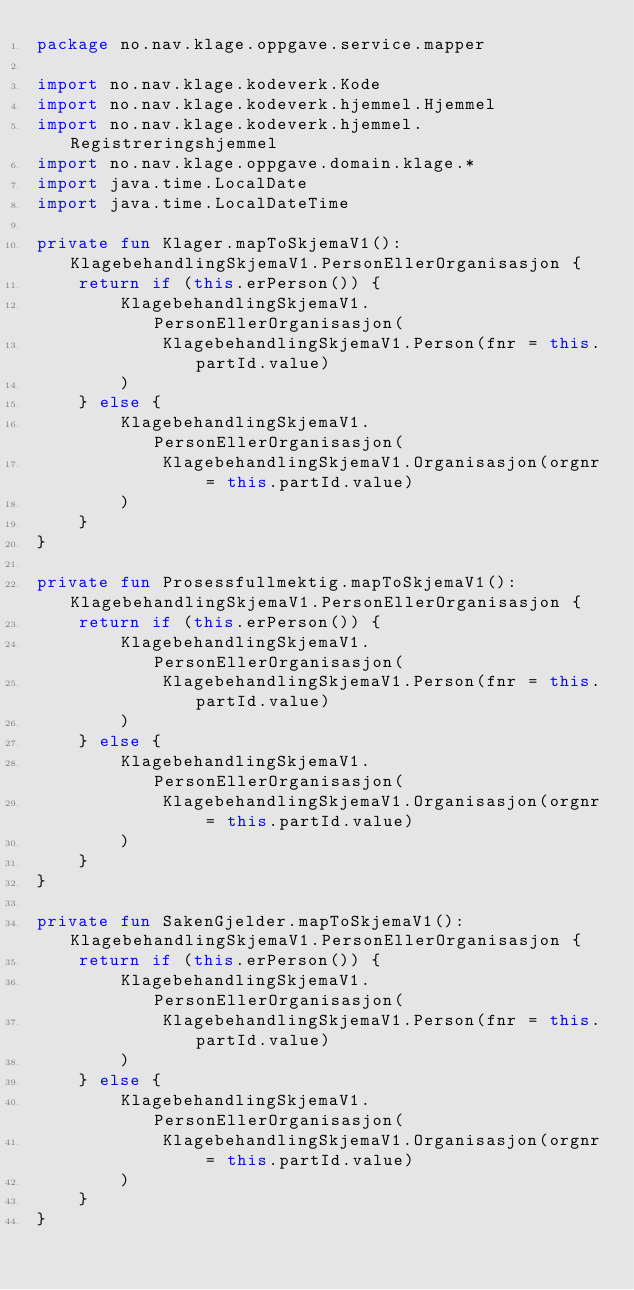<code> <loc_0><loc_0><loc_500><loc_500><_Kotlin_>package no.nav.klage.oppgave.service.mapper

import no.nav.klage.kodeverk.Kode
import no.nav.klage.kodeverk.hjemmel.Hjemmel
import no.nav.klage.kodeverk.hjemmel.Registreringshjemmel
import no.nav.klage.oppgave.domain.klage.*
import java.time.LocalDate
import java.time.LocalDateTime

private fun Klager.mapToSkjemaV1(): KlagebehandlingSkjemaV1.PersonEllerOrganisasjon {
    return if (this.erPerson()) {
        KlagebehandlingSkjemaV1.PersonEllerOrganisasjon(
            KlagebehandlingSkjemaV1.Person(fnr = this.partId.value)
        )
    } else {
        KlagebehandlingSkjemaV1.PersonEllerOrganisasjon(
            KlagebehandlingSkjemaV1.Organisasjon(orgnr = this.partId.value)
        )
    }
}

private fun Prosessfullmektig.mapToSkjemaV1(): KlagebehandlingSkjemaV1.PersonEllerOrganisasjon {
    return if (this.erPerson()) {
        KlagebehandlingSkjemaV1.PersonEllerOrganisasjon(
            KlagebehandlingSkjemaV1.Person(fnr = this.partId.value)
        )
    } else {
        KlagebehandlingSkjemaV1.PersonEllerOrganisasjon(
            KlagebehandlingSkjemaV1.Organisasjon(orgnr = this.partId.value)
        )
    }
}

private fun SakenGjelder.mapToSkjemaV1(): KlagebehandlingSkjemaV1.PersonEllerOrganisasjon {
    return if (this.erPerson()) {
        KlagebehandlingSkjemaV1.PersonEllerOrganisasjon(
            KlagebehandlingSkjemaV1.Person(fnr = this.partId.value)
        )
    } else {
        KlagebehandlingSkjemaV1.PersonEllerOrganisasjon(
            KlagebehandlingSkjemaV1.Organisasjon(orgnr = this.partId.value)
        )
    }
}
</code> 